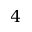<formula> <loc_0><loc_0><loc_500><loc_500>4</formula> 